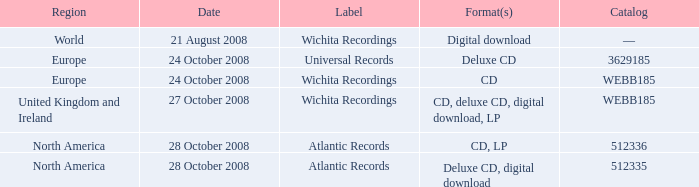Which area is linked with the catalog value of 512335? North America. 